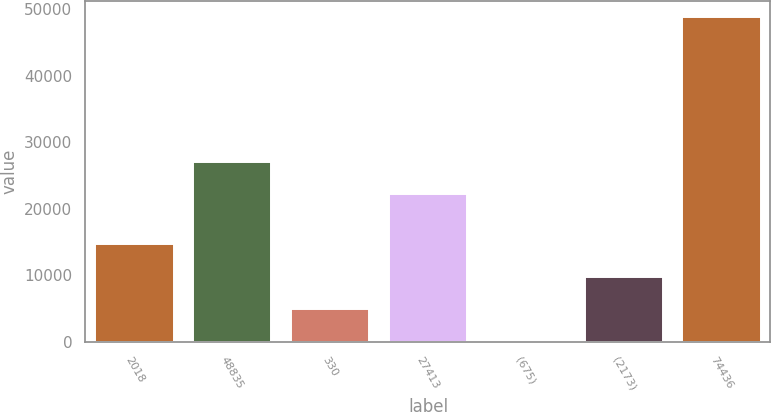<chart> <loc_0><loc_0><loc_500><loc_500><bar_chart><fcel>2018<fcel>48835<fcel>330<fcel>27413<fcel>(675)<fcel>(2173)<fcel>74436<nl><fcel>14665.2<fcel>27083.4<fcel>4902.4<fcel>22202<fcel>21<fcel>9783.8<fcel>48835<nl></chart> 